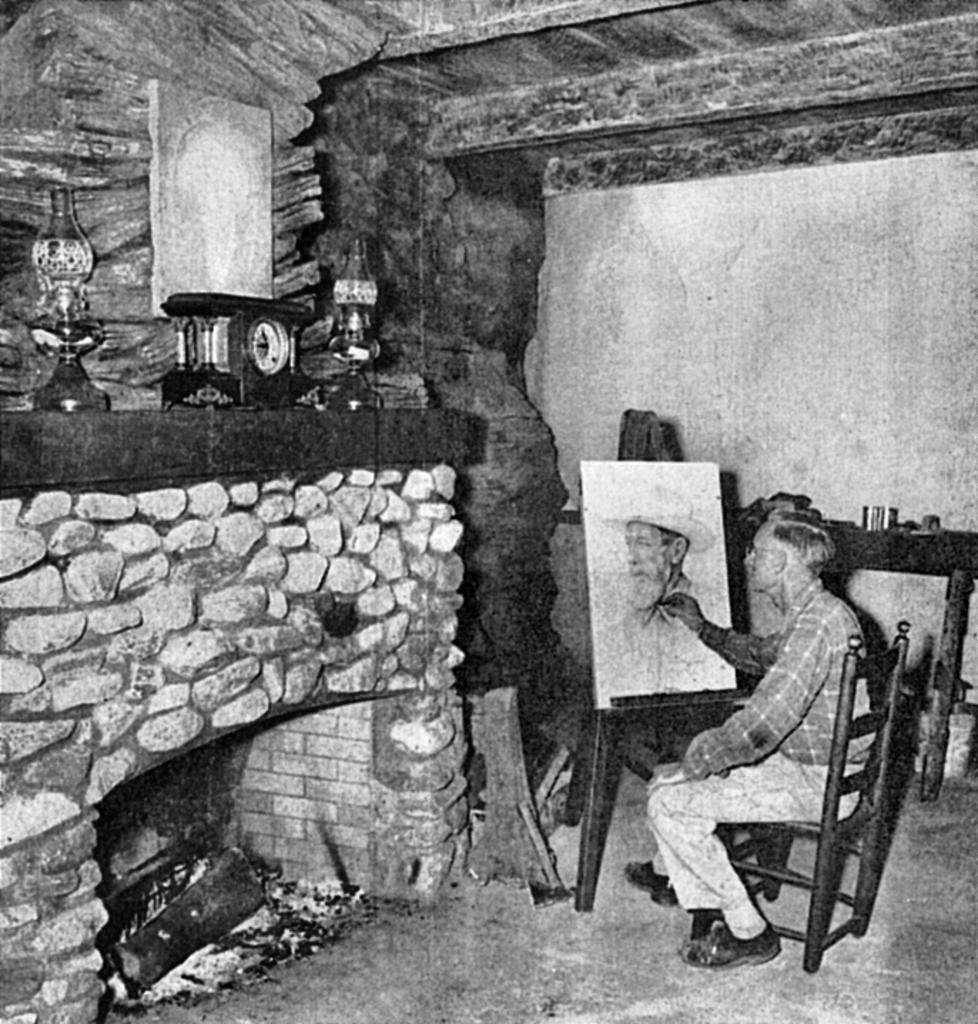Please provide a concise description of this image. This is a black and white image. There is a person sitting on a chair, on the right side. He is drawing something. There are clock and lamps on the left side. There is a fireplace on the left side. 